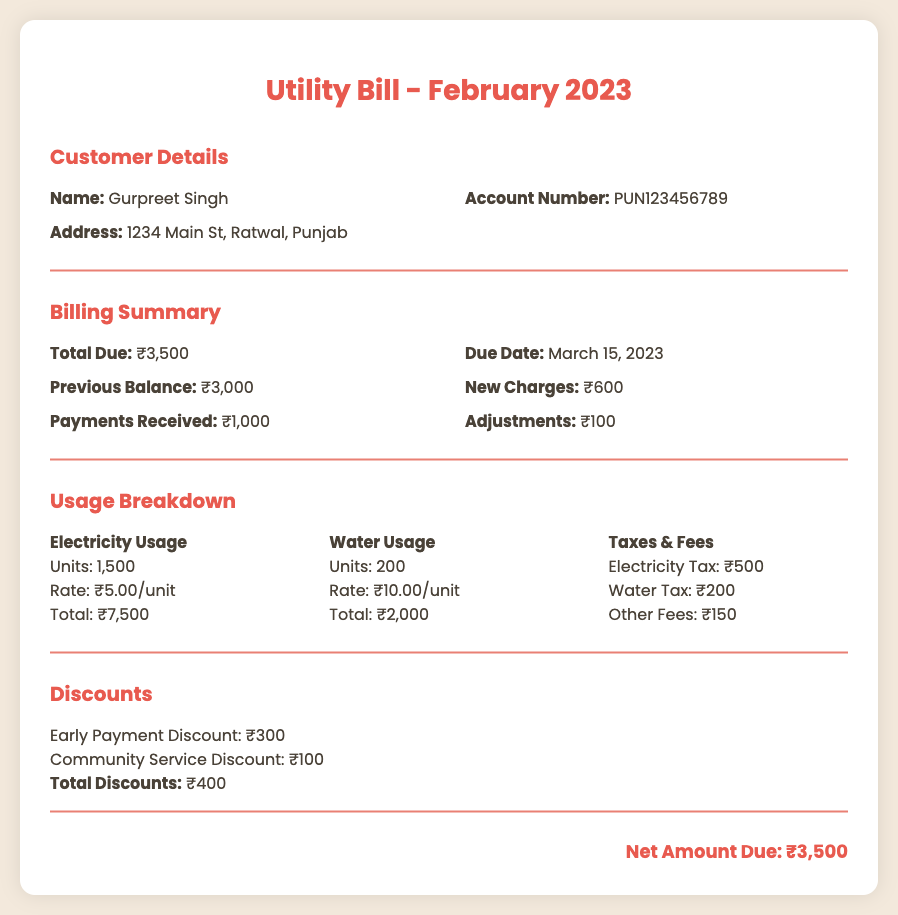What is the account number? The account number is provided in the customer details section of the document.
Answer: PUN123456789 Who is the customer? The customer's name appears at the top of the customer details section.
Answer: Gurpreet Singh What is the total due amount? The total due amount is specified in the billing summary section of the document.
Answer: ₹3,500 When is the due date for payment? The due date is listed in the billing summary for payments.
Answer: March 15, 2023 What are the total discounts? The total discounts are calculated from the discounts section at the bottom of the document.
Answer: ₹400 How much was received in payments? The amount of payments received is detailed in the billing summary section.
Answer: ₹1,000 What is the rate for electricity usage? The rate for electricity can be found in the usage breakdown section under electricity usage.
Answer: ₹5.00/unit How many units of water were used? The number of water units used is provided in the usage breakdown section of the document.
Answer: 200 What is the electricity tax amount? The electricity tax is specified within the taxes and fees section of the usage breakdown.
Answer: ₹500 